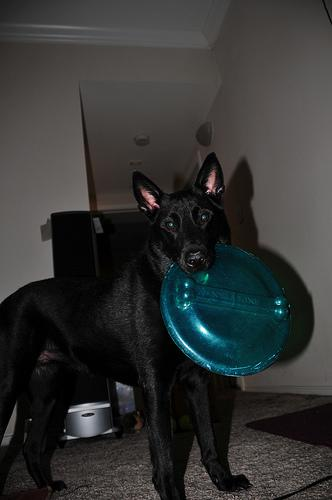Question: what does the dog have in his mouth?
Choices:
A. Frisbee.
B. A ball.
C. A stuffed animal.
D. A toy.
Answer with the letter. Answer: A Question: how many animals are in this picture?
Choices:
A. 2.
B. 3.
C. 4.
D. 1.
Answer with the letter. Answer: D Question: what color are the inside of the dogs ears?
Choices:
A. Orange.
B. Brown.
C. Pink.
D. Blue.
Answer with the letter. Answer: C Question: who is holding the frisbee?
Choices:
A. Boy.
B. Woman.
C. Man.
D. Dog.
Answer with the letter. Answer: D 